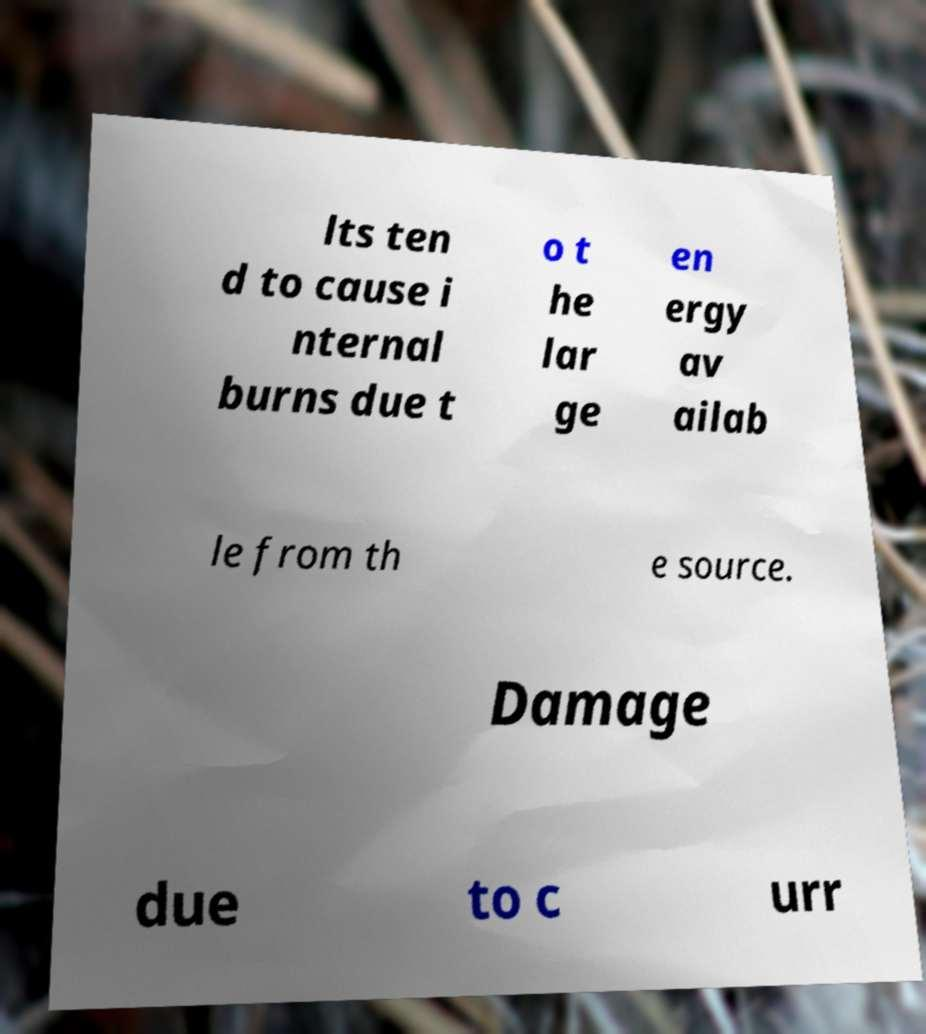Can you read and provide the text displayed in the image?This photo seems to have some interesting text. Can you extract and type it out for me? lts ten d to cause i nternal burns due t o t he lar ge en ergy av ailab le from th e source. Damage due to c urr 